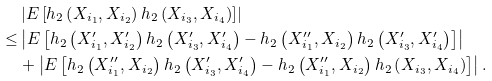Convert formula to latex. <formula><loc_0><loc_0><loc_500><loc_500>& \left | E \left [ h _ { 2 } \left ( X _ { i _ { 1 } } , X _ { i _ { 2 } } \right ) h _ { 2 } \left ( X _ { i _ { 3 } } , X _ { i _ { 4 } } \right ) \right ] \right | \\ \leq & \left | E \left [ h _ { 2 } \left ( X ^ { \prime } _ { i _ { 1 } } , X ^ { \prime } _ { i _ { 2 } } \right ) h _ { 2 } \left ( X ^ { \prime } _ { i _ { 3 } } , X ^ { \prime } _ { i _ { 4 } } \right ) - h _ { 2 } \left ( X ^ { \prime \prime } _ { i _ { 1 } } , X _ { i _ { 2 } } \right ) h _ { 2 } \left ( X ^ { \prime } _ { i _ { 3 } } , X ^ { \prime } _ { i _ { 4 } } \right ) \right ] \right | \\ & + \left | E \left [ h _ { 2 } \left ( X ^ { \prime \prime } _ { i _ { 1 } } , X _ { i _ { 2 } } \right ) h _ { 2 } \left ( X ^ { \prime } _ { i _ { 3 } } , X ^ { \prime } _ { i _ { 4 } } \right ) - h _ { 2 } \left ( X ^ { \prime \prime } _ { i _ { 1 } } , X _ { i _ { 2 } } \right ) h _ { 2 } \left ( X _ { i _ { 3 } } , X _ { i _ { 4 } } \right ) \right ] \right | .</formula> 